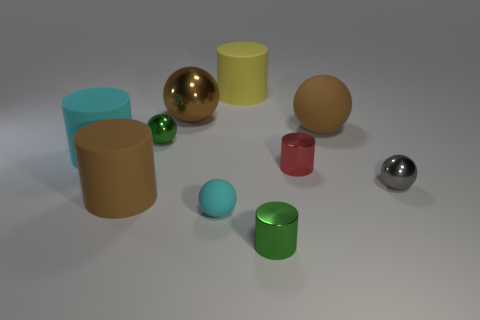Subtract all small gray metal balls. How many balls are left? 4 Subtract all brown cubes. How many brown spheres are left? 2 Subtract all brown cylinders. How many cylinders are left? 4 Subtract 2 balls. How many balls are left? 3 Subtract 1 gray balls. How many objects are left? 9 Subtract all purple spheres. Subtract all gray cylinders. How many spheres are left? 5 Subtract all big yellow things. Subtract all shiny cylinders. How many objects are left? 7 Add 5 matte things. How many matte things are left? 10 Add 3 tiny red metallic things. How many tiny red metallic things exist? 4 